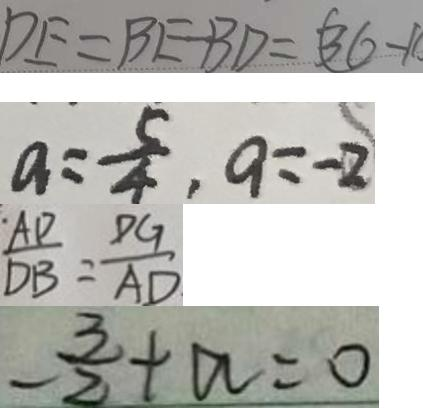<formula> <loc_0><loc_0><loc_500><loc_500>D E = B E - B D = ( 3 6 - 1 
 a = \frac { 5 } { 4 } , a = - 2 
 \frac { A D } { D B } = \frac { D G } { A D } 
 - \frac { 3 } { 2 } + a = 0</formula> 